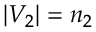<formula> <loc_0><loc_0><loc_500><loc_500>| V _ { 2 } | = n _ { 2 }</formula> 